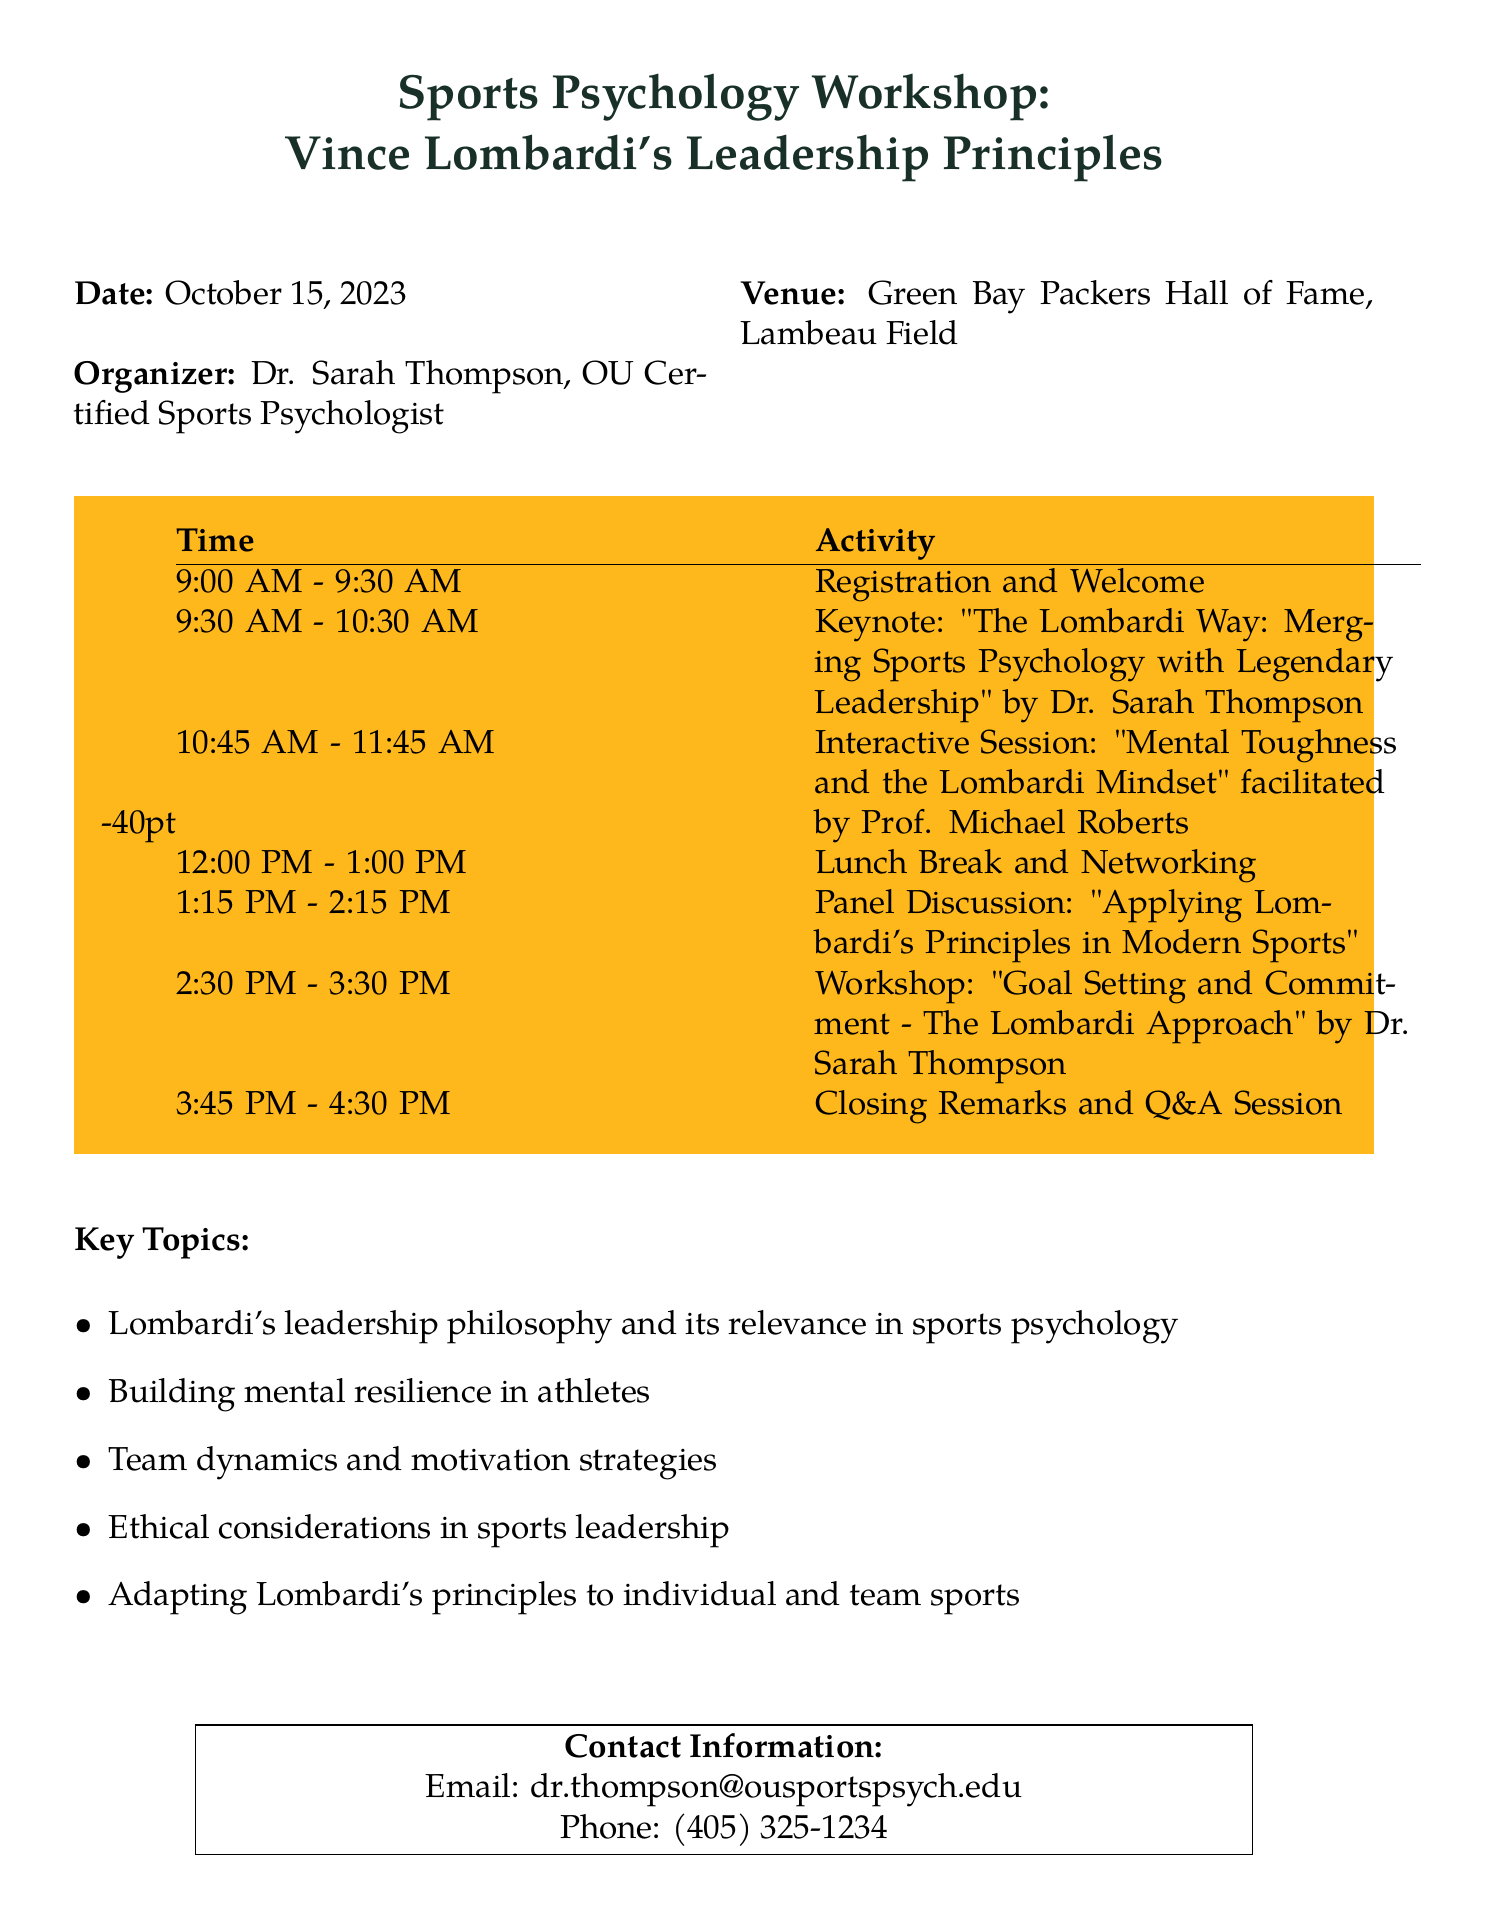What is the date of the workshop? The date of the workshop is specifically mentioned in the document as October 15, 2023.
Answer: October 15, 2023 Who is the organizer of the workshop? The document states that the organizer is Dr. Sarah Thompson, an OU Certified Sports Psychologist.
Answer: Dr. Sarah Thompson What time does the registration start? The schedule indicates that registration and welcome start at 9:00 AM.
Answer: 9:00 AM What is the title of the keynote speech? The document lists the keynote speech as "The Lombardi Way: Merging Sports Psychology with Legendary Leadership" by Dr. Sarah Thompson.
Answer: The Lombardi Way: Merging Sports Psychology with Legendary Leadership Who is facilitating the interactive session? The interactive session is facilitated by Prof. Michael Roberts, as mentioned in the activity schedule.
Answer: Prof. Michael Roberts How long is the lunch break? The schedule specifies a lunch break duration of one hour from 12:00 PM to 1:00 PM.
Answer: 1 hour What is one key topic discussed in the workshop? The document lists multiple key topics, one of which is "Team dynamics and motivation strategies."
Answer: Team dynamics and motivation strategies What time does the closing remarks session begin? The schedule indicates that closing remarks and the Q&A session begin at 3:45 PM.
Answer: 3:45 PM What is the venue for the workshop? The venue for the workshop according to the document is the Green Bay Packers Hall of Fame, Lambeau Field.
Answer: Green Bay Packers Hall of Fame, Lambeau Field 